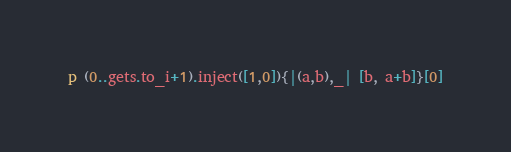<code> <loc_0><loc_0><loc_500><loc_500><_Ruby_>p (0..gets.to_i+1).inject([1,0]){|(a,b),_| [b, a+b]}[0]</code> 